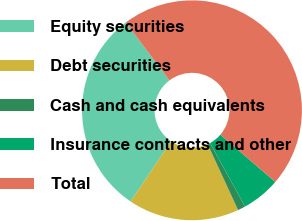Convert chart. <chart><loc_0><loc_0><loc_500><loc_500><pie_chart><fcel>Equity securities<fcel>Debt securities<fcel>Cash and cash equivalents<fcel>Insurance contracts and other<fcel>Total<nl><fcel>30.29%<fcel>16.31%<fcel>1.13%<fcel>5.68%<fcel>46.59%<nl></chart> 